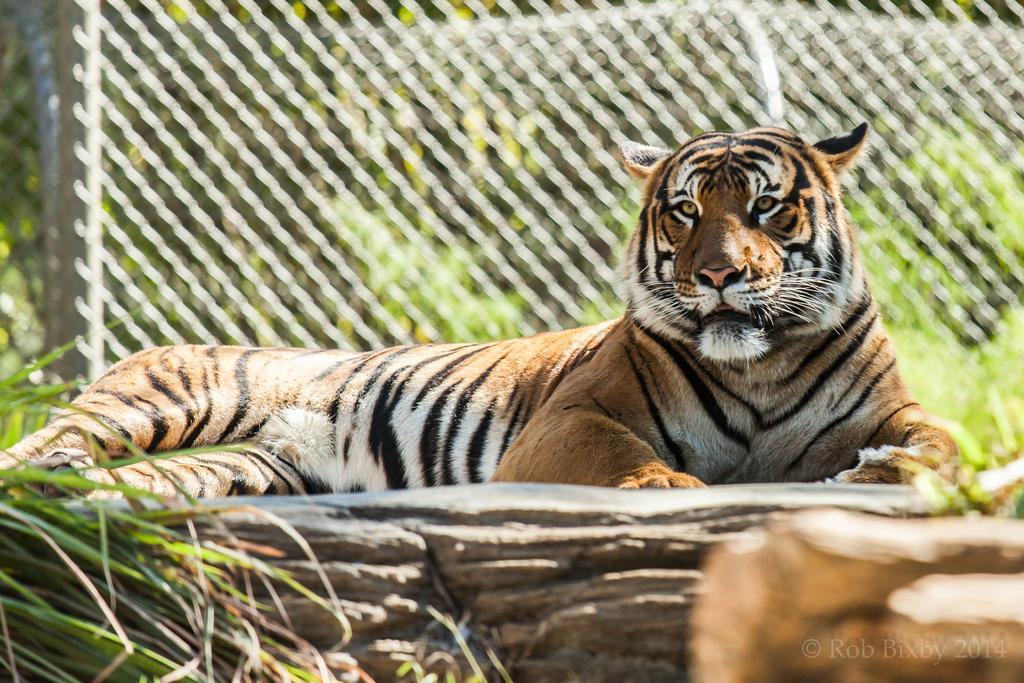How would you summarize this image in a sentence or two? In this image there is a tiger sitting on a rock. Left bottom there is some grass. Background there is a fence. Behind there are trees and plants. 